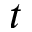Convert formula to latex. <formula><loc_0><loc_0><loc_500><loc_500>t</formula> 